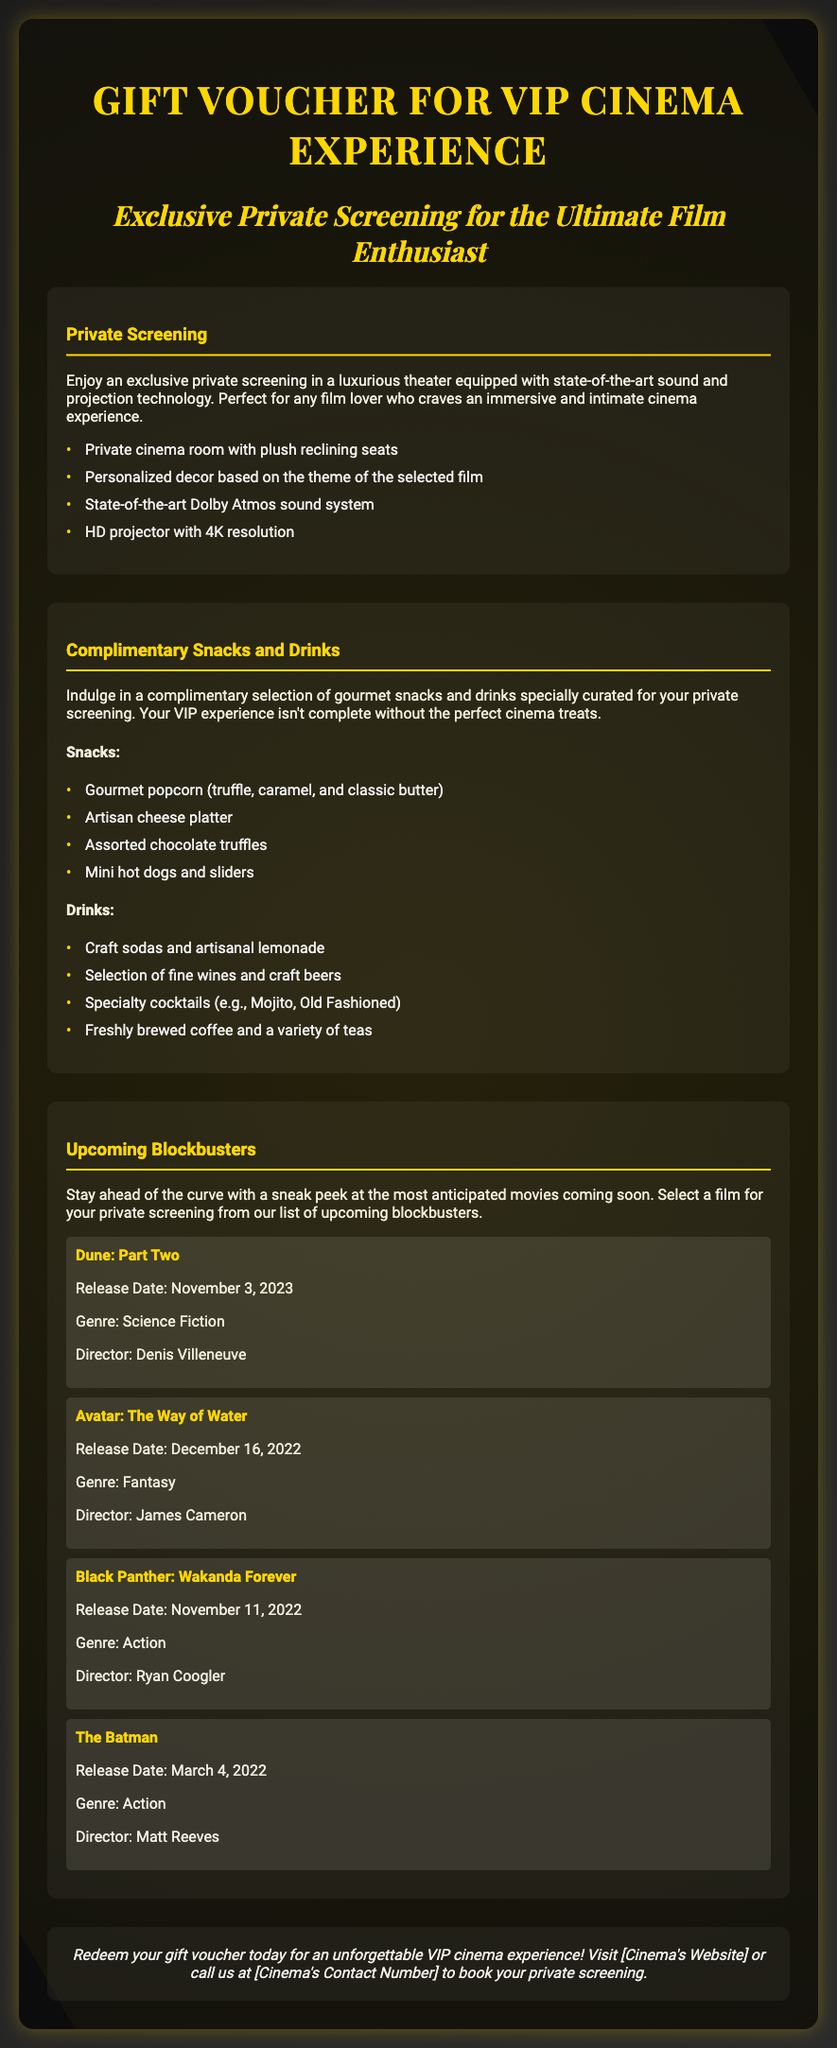What is the title of the gift voucher? The title is prominently displayed at the top of the document as the name of the voucher.
Answer: Gift Voucher for VIP Cinema Experience What is the release date of "Dune: Part Two"? The release date is mentioned under the details of the movie and is important for viewer awareness.
Answer: November 3, 2023 What type of seating is provided in the private screening? This detail highlights the comfort aspect of the movie-watching experience.
Answer: Plush reclining seats What drinks are included in the complimentary menu? The drinks list showcases the variety available during the screening, emphasizing the VIP experience.
Answer: Craft sodas and artisanal lemonade How many upcoming blockbuster films are listed? The number of films is significant as it indicates the options available for screenings.
Answer: Four What is the genre of "The Batman"? Knowing the genre helps in characterizing the film and in choosing preferences for screenings.
Answer: Action What special feature enhances the sound experience in the cinema? This feature highlights the technological sophistication of the cinema, appealing to film enthusiasts.
Answer: Dolby Atmos sound system What type of event does this gift voucher offer? Understanding the nature of the voucher helps in knowing its exclusivity and purpose.
Answer: Exclusive Private Screening What is a key feature of the complimentary snacks? This detail emphasizes the luxurious offerings included with the voucher.
Answer: Gourmet popcorn (truffle, caramel, and classic butter) 